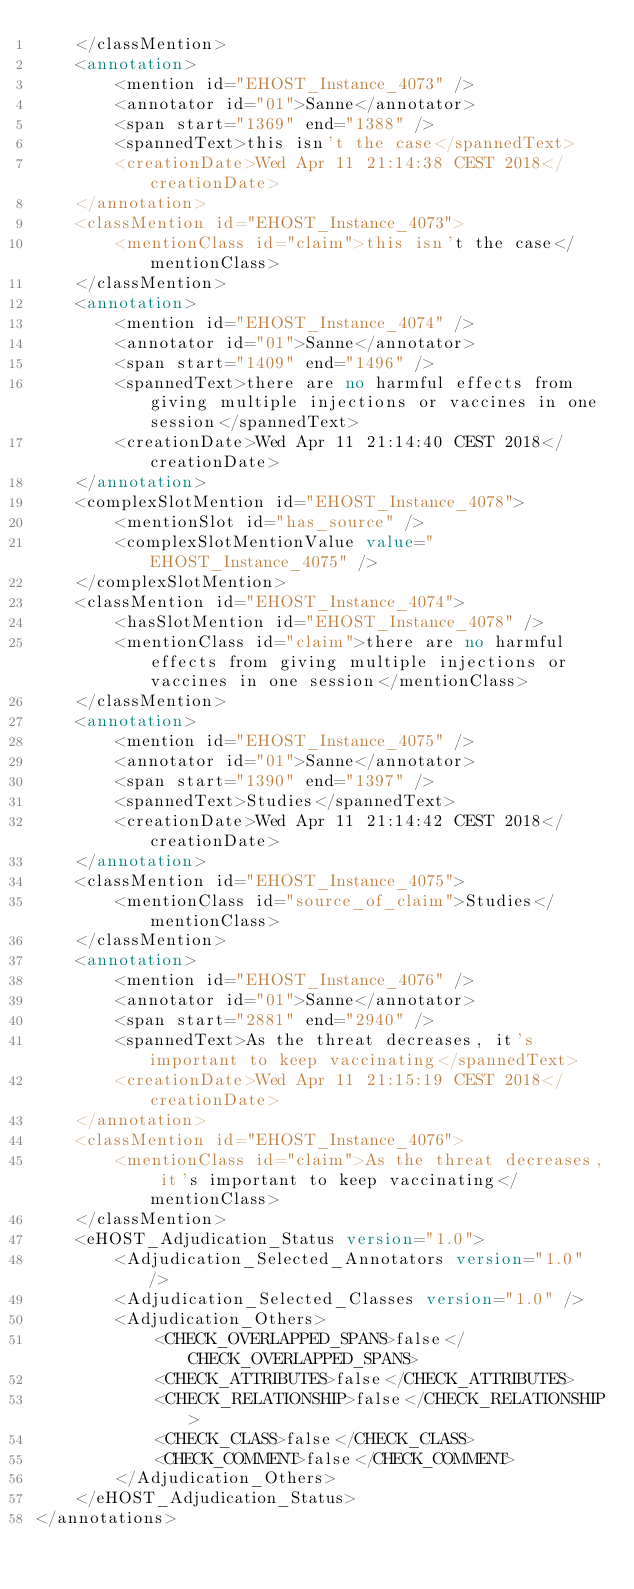<code> <loc_0><loc_0><loc_500><loc_500><_XML_>    </classMention>
    <annotation>
        <mention id="EHOST_Instance_4073" />
        <annotator id="01">Sanne</annotator>
        <span start="1369" end="1388" />
        <spannedText>this isn't the case</spannedText>
        <creationDate>Wed Apr 11 21:14:38 CEST 2018</creationDate>
    </annotation>
    <classMention id="EHOST_Instance_4073">
        <mentionClass id="claim">this isn't the case</mentionClass>
    </classMention>
    <annotation>
        <mention id="EHOST_Instance_4074" />
        <annotator id="01">Sanne</annotator>
        <span start="1409" end="1496" />
        <spannedText>there are no harmful effects from giving multiple injections or vaccines in one session</spannedText>
        <creationDate>Wed Apr 11 21:14:40 CEST 2018</creationDate>
    </annotation>
    <complexSlotMention id="EHOST_Instance_4078">
        <mentionSlot id="has_source" />
        <complexSlotMentionValue value="EHOST_Instance_4075" />
    </complexSlotMention>
    <classMention id="EHOST_Instance_4074">
        <hasSlotMention id="EHOST_Instance_4078" />
        <mentionClass id="claim">there are no harmful effects from giving multiple injections or vaccines in one session</mentionClass>
    </classMention>
    <annotation>
        <mention id="EHOST_Instance_4075" />
        <annotator id="01">Sanne</annotator>
        <span start="1390" end="1397" />
        <spannedText>Studies</spannedText>
        <creationDate>Wed Apr 11 21:14:42 CEST 2018</creationDate>
    </annotation>
    <classMention id="EHOST_Instance_4075">
        <mentionClass id="source_of_claim">Studies</mentionClass>
    </classMention>
    <annotation>
        <mention id="EHOST_Instance_4076" />
        <annotator id="01">Sanne</annotator>
        <span start="2881" end="2940" />
        <spannedText>As the threat decreases, it's important to keep vaccinating</spannedText>
        <creationDate>Wed Apr 11 21:15:19 CEST 2018</creationDate>
    </annotation>
    <classMention id="EHOST_Instance_4076">
        <mentionClass id="claim">As the threat decreases, it's important to keep vaccinating</mentionClass>
    </classMention>
    <eHOST_Adjudication_Status version="1.0">
        <Adjudication_Selected_Annotators version="1.0" />
        <Adjudication_Selected_Classes version="1.0" />
        <Adjudication_Others>
            <CHECK_OVERLAPPED_SPANS>false</CHECK_OVERLAPPED_SPANS>
            <CHECK_ATTRIBUTES>false</CHECK_ATTRIBUTES>
            <CHECK_RELATIONSHIP>false</CHECK_RELATIONSHIP>
            <CHECK_CLASS>false</CHECK_CLASS>
            <CHECK_COMMENT>false</CHECK_COMMENT>
        </Adjudication_Others>
    </eHOST_Adjudication_Status>
</annotations>

</code> 